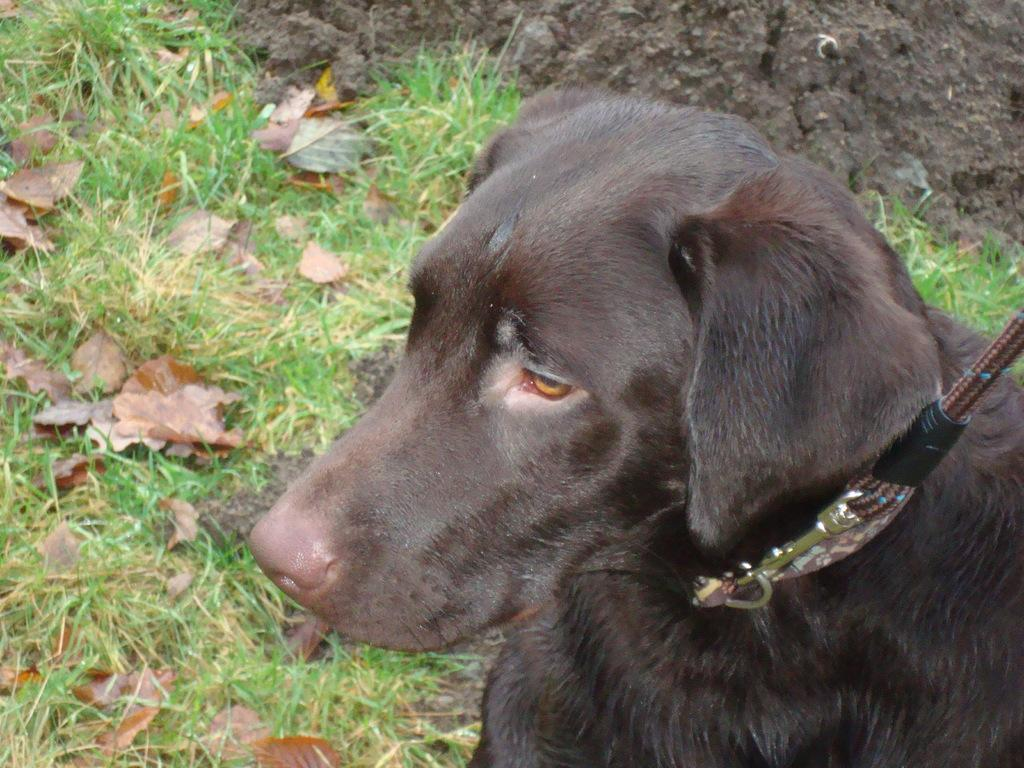What type of vegetation is on the left side of the image? There is grass on the left side of the image. What animal is in the middle of the image? There is a dog in the middle of the image. What is the color of the dog? The dog is black in color. What is the dog wearing? The dog has a belt. Can you see any sheep in the image? There are no sheep present in the image. Is the dog walking at night in the image? The time of day is not mentioned in the image, and there is no indication of nighttime. Additionally, the dog is not shown walking. 